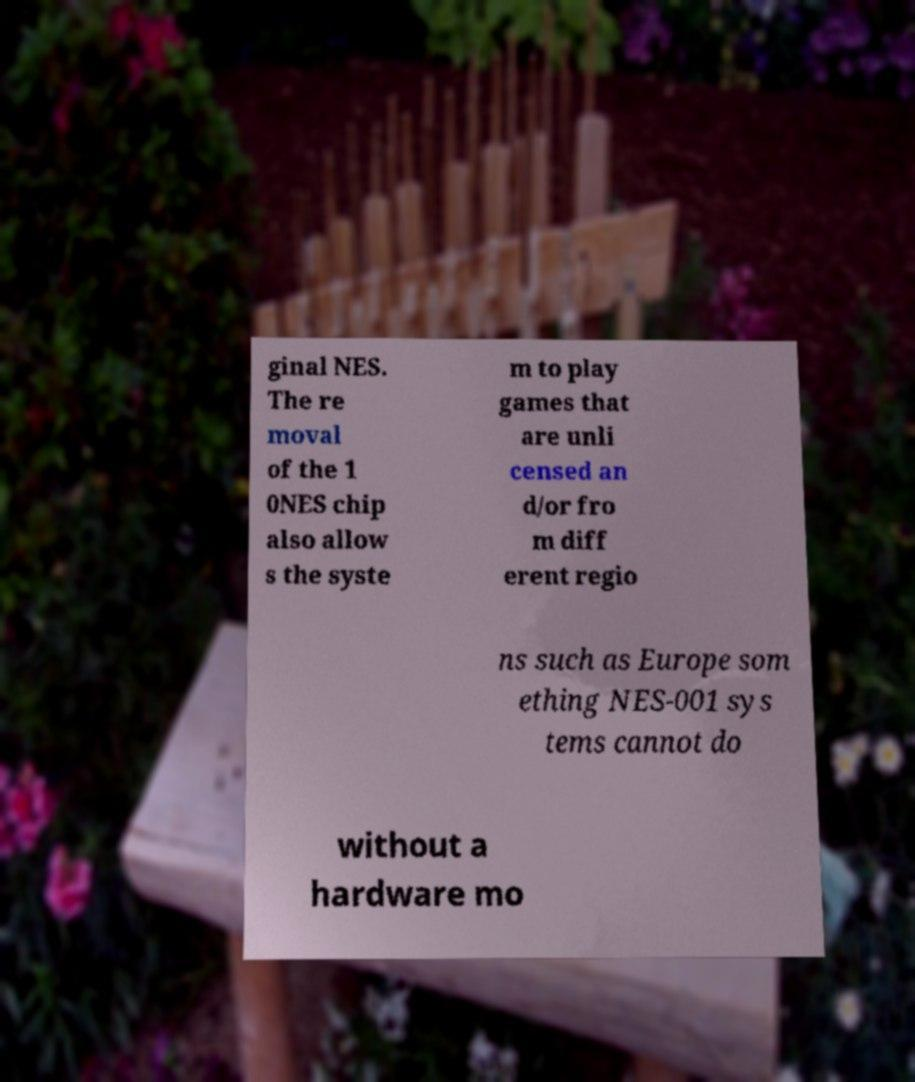There's text embedded in this image that I need extracted. Can you transcribe it verbatim? ginal NES. The re moval of the 1 0NES chip also allow s the syste m to play games that are unli censed an d/or fro m diff erent regio ns such as Europe som ething NES-001 sys tems cannot do without a hardware mo 